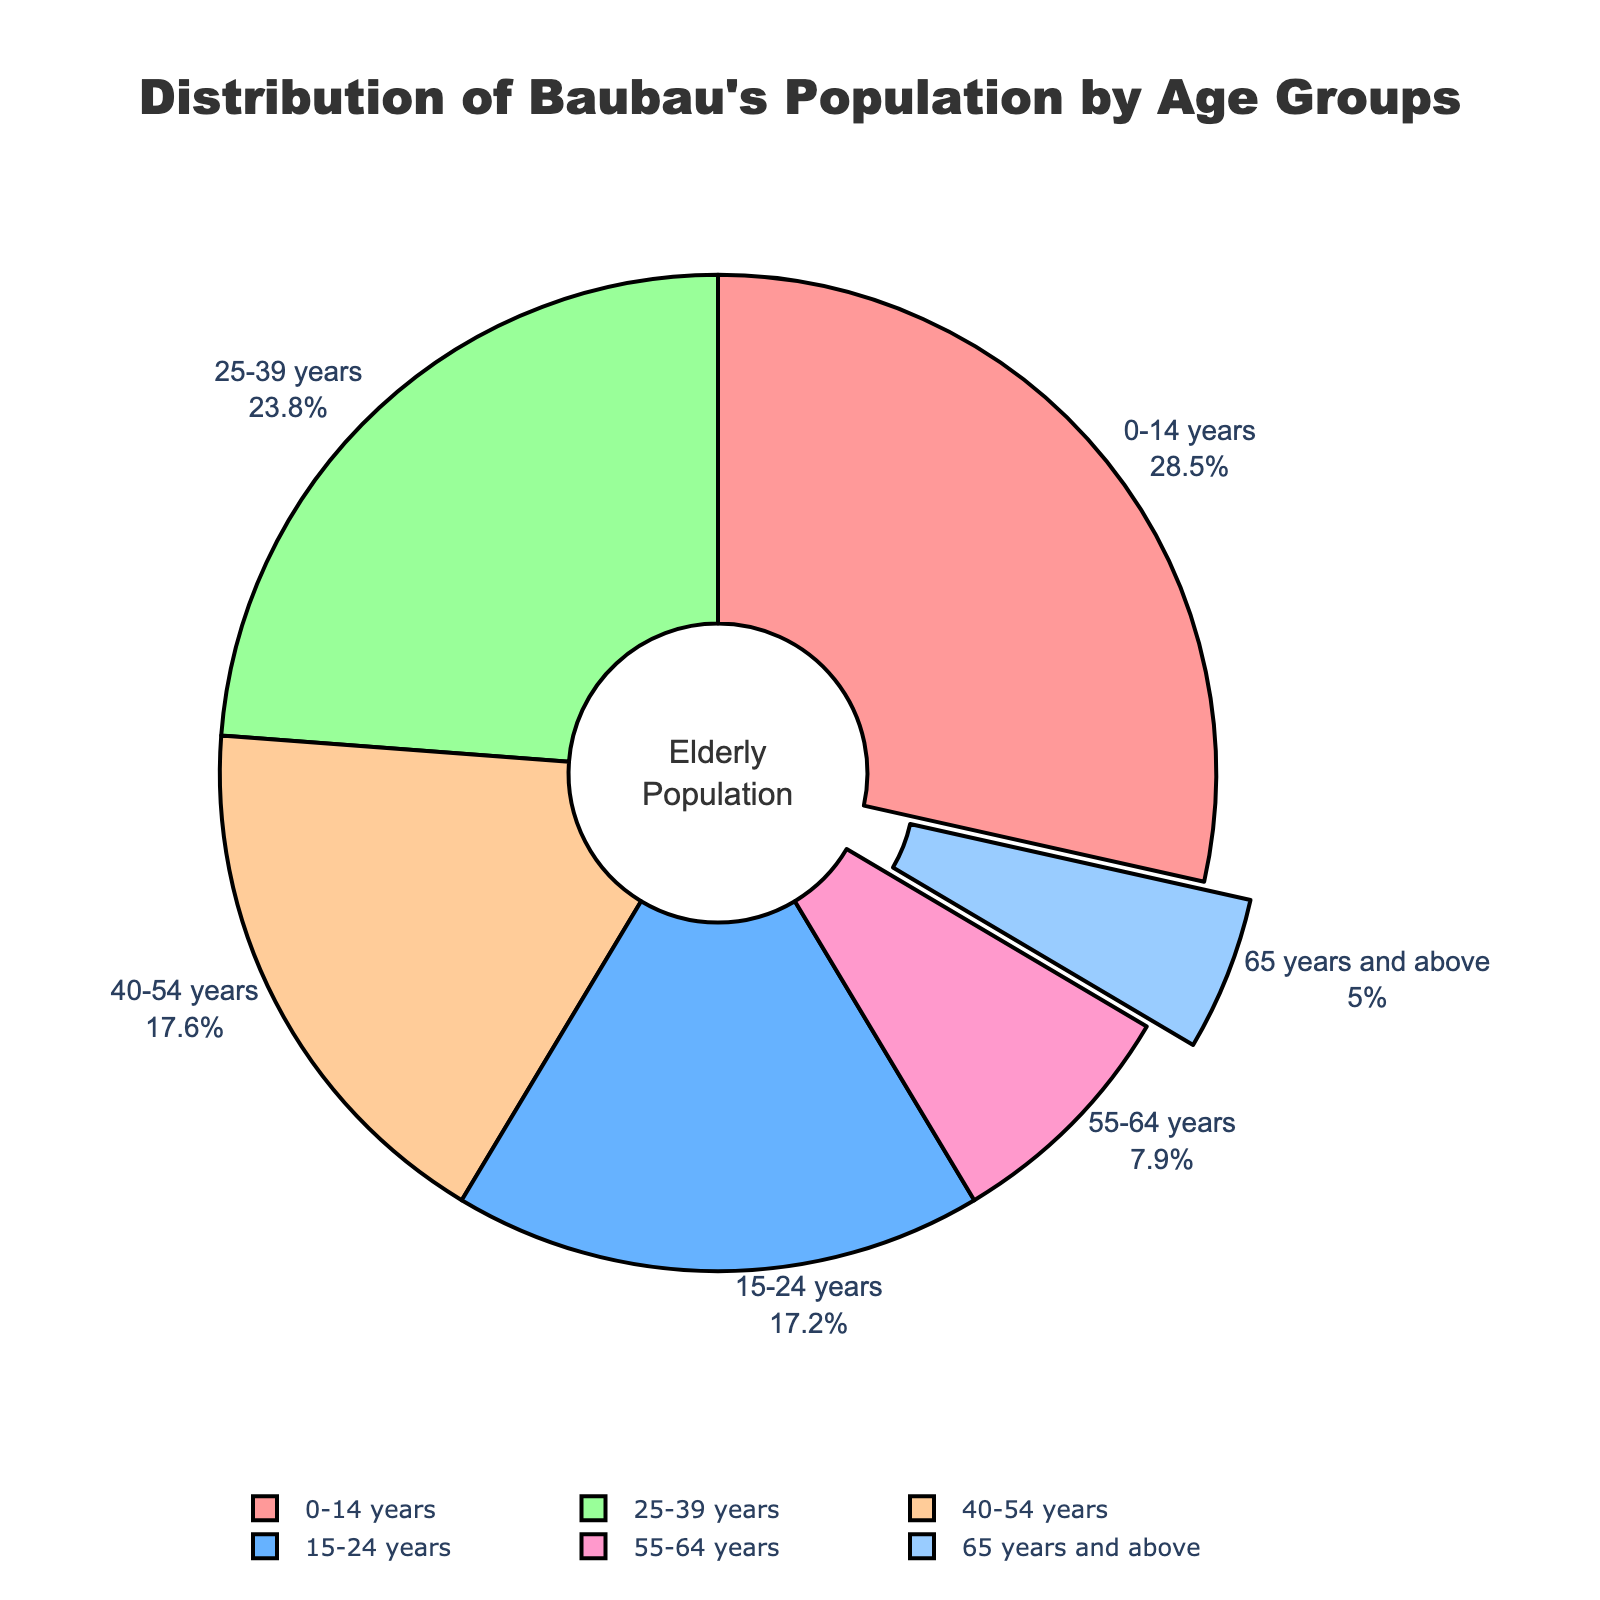What percentage of Baubau's population is 65 years and above? Look at the segment of the pie chart labeled "65 years and above" and note the percentage.
Answer: 5.0% Which age group has the highest population percentage? Identify the largest segment in the pie chart by the label and percentage value.
Answer: 0-14 years What’s the combined population percentage of the 55-64 years and 65 years and above groups? Add the population percentages of the 55-64 years group (7.9%) and the 65 years and above group (5.0%). 7.9 + 5.0 = 12.9
Answer: 12.9% Is the population percentage of 25-39 years larger than that of 15-24 years? Compare the population percentage value of the 25-39 years group (23.8%) and the 15-24 years group (17.2%). 23.8 is greater than 17.2.
Answer: Yes Which two age groups combined make up about half of Baubau's population? Look for two age groups whose percentages add up to around 50%. The 0-14 years (28.5%) and 25-39 years (23.8%) together: 28.5 + 23.8 = 52.3.
Answer: 0-14 years and 25-39 years What is the color of the segment representing the elderly population (65 years and above)? Observe the color of the "65 years and above" segment in the pie chart.
Answer: Light blue How much more percent is the population of 0-14 years compared to 15-24 years? Subtract the population percentage of the 15-24 years group (17.2%) from the 0-14 years group (28.5%). 28.5 - 17.2 = 11.3
Answer: 11.3% Which age group has the smallest population percentage? Identify the smallest segment in the pie chart by the label and percentage value.
Answer: 65 years and above 